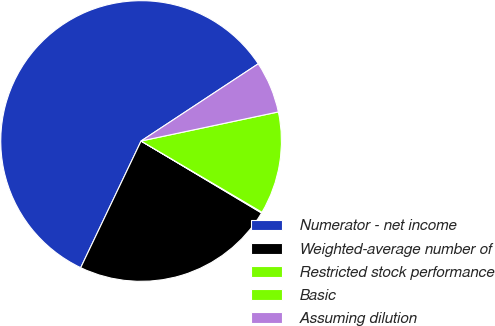<chart> <loc_0><loc_0><loc_500><loc_500><pie_chart><fcel>Numerator - net income<fcel>Weighted-average number of<fcel>Restricted stock performance<fcel>Basic<fcel>Assuming dilution<nl><fcel>58.64%<fcel>23.51%<fcel>0.09%<fcel>11.8%<fcel>5.95%<nl></chart> 